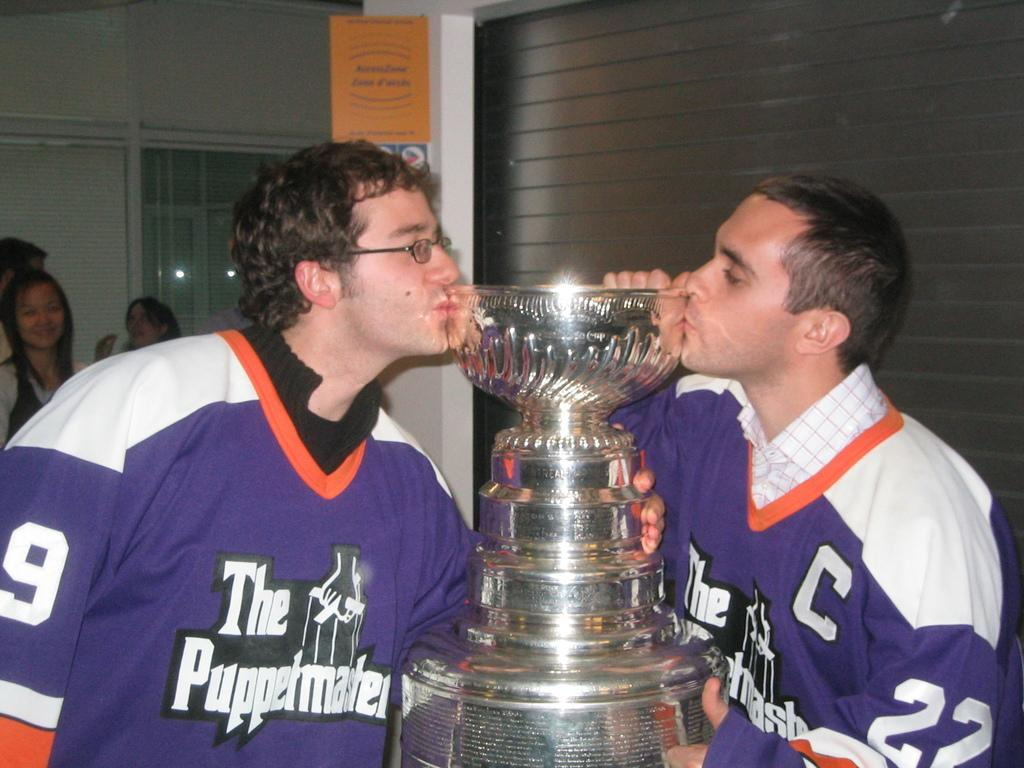<image>
Render a clear and concise summary of the photo. Two guys wearing hockey jerseys for The Puppetmasters kiss a trophy with the 